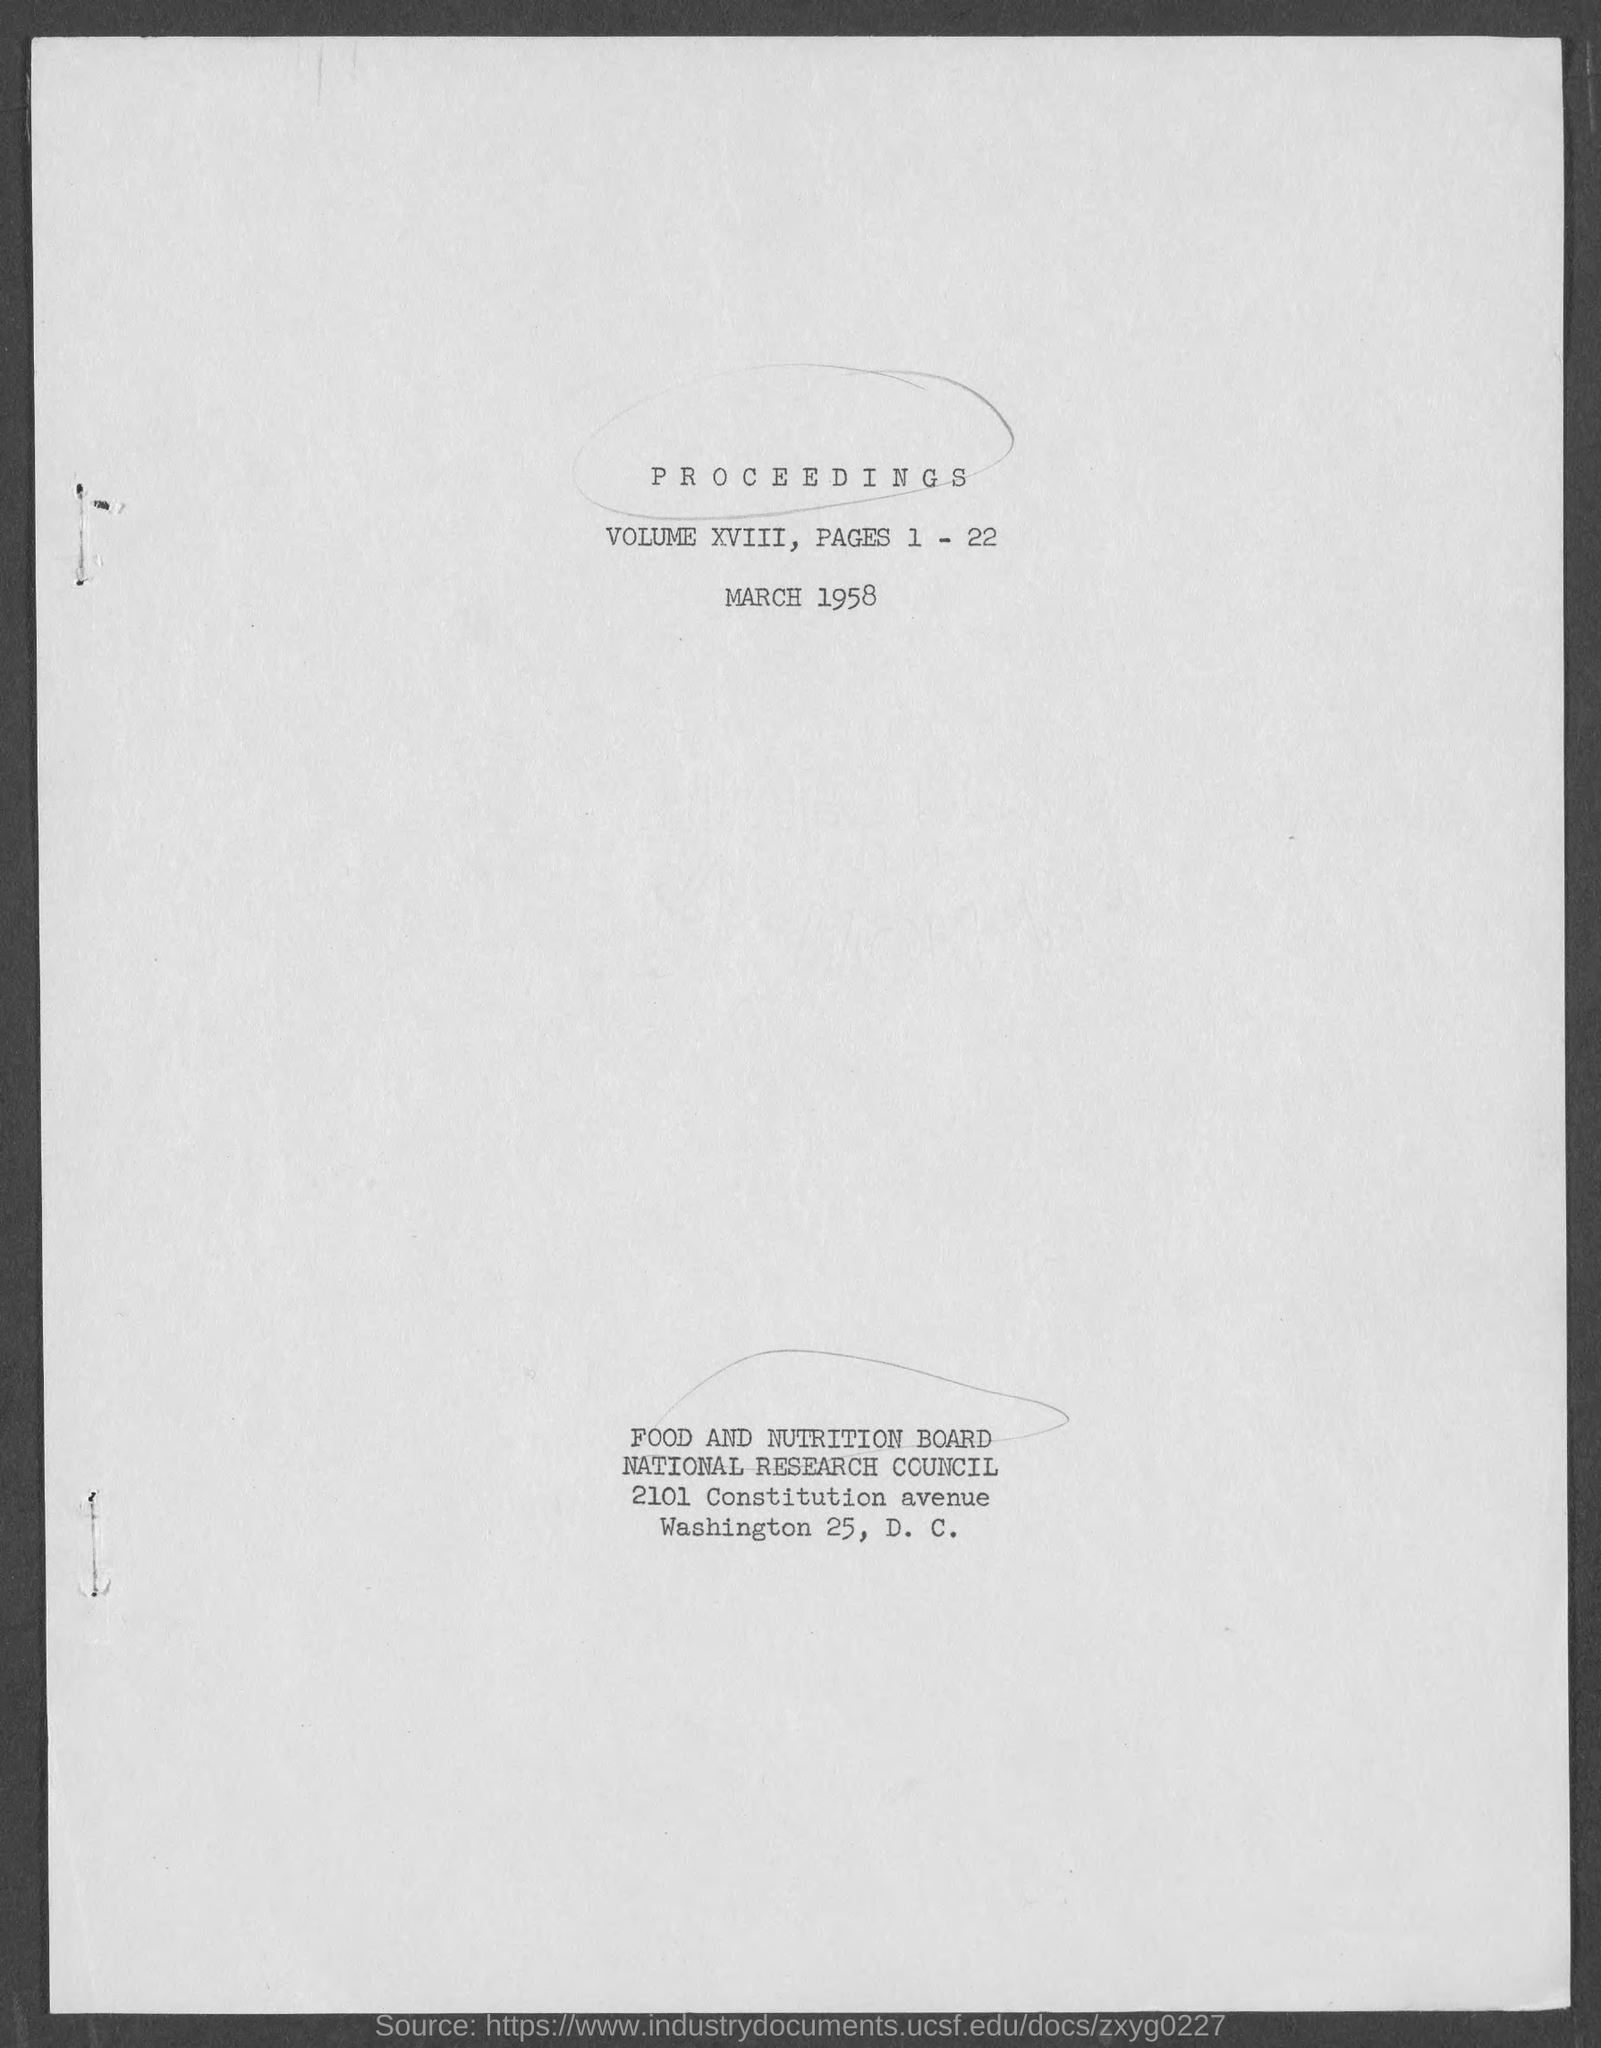What is the volume no.?
Your response must be concise. XVIII. What is the content of volume xviii?
Your answer should be compact. PROCEEDINGS. What is the issued date of the volume?
Give a very brief answer. MARCH 1958. 